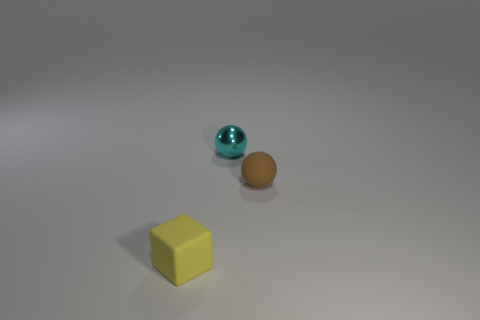Is the number of small objects in front of the small brown rubber ball greater than the number of big rubber objects?
Your answer should be very brief. Yes. What number of objects are either rubber objects or tiny objects that are behind the tiny yellow matte block?
Give a very brief answer. 3. Are there more objects than cubes?
Ensure brevity in your answer.  Yes. Are there any small spheres made of the same material as the yellow object?
Ensure brevity in your answer.  Yes. The object that is both in front of the tiny cyan shiny thing and on the left side of the brown rubber ball has what shape?
Make the answer very short. Cube. What number of other objects are there of the same shape as the metallic object?
Your response must be concise. 1. How big is the brown ball?
Offer a very short reply. Small. How many things are either large blue matte balls or small metallic spheres?
Make the answer very short. 1. There is a thing that is in front of the shiny object and to the right of the small yellow matte thing; what is its color?
Give a very brief answer. Brown. Is the material of the small ball behind the small brown rubber thing the same as the tiny brown thing?
Your response must be concise. No. 